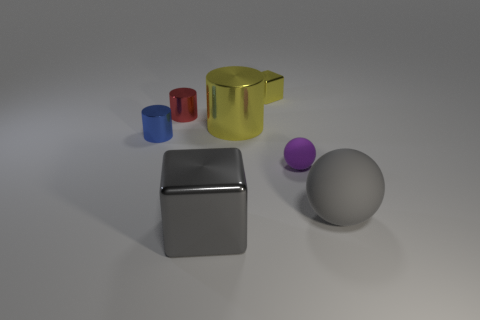Is there a metal block that has the same color as the large matte object?
Ensure brevity in your answer.  Yes. Are there any brown objects made of the same material as the tiny red cylinder?
Your answer should be very brief. No. There is a thing that is both on the left side of the large sphere and to the right of the small yellow metallic block; what is its shape?
Offer a terse response. Sphere. How many big things are brown cubes or gray blocks?
Your response must be concise. 1. What material is the red object?
Ensure brevity in your answer.  Metal. How many other things are there of the same shape as the tiny yellow object?
Offer a very short reply. 1. How big is the purple sphere?
Provide a succinct answer. Small. There is a metal thing that is in front of the large metal cylinder and behind the gray metallic block; what size is it?
Keep it short and to the point. Small. What is the shape of the small metallic object on the right side of the gray block?
Your answer should be very brief. Cube. Do the big yellow cylinder and the big gray thing that is on the right side of the yellow metal block have the same material?
Give a very brief answer. No. 